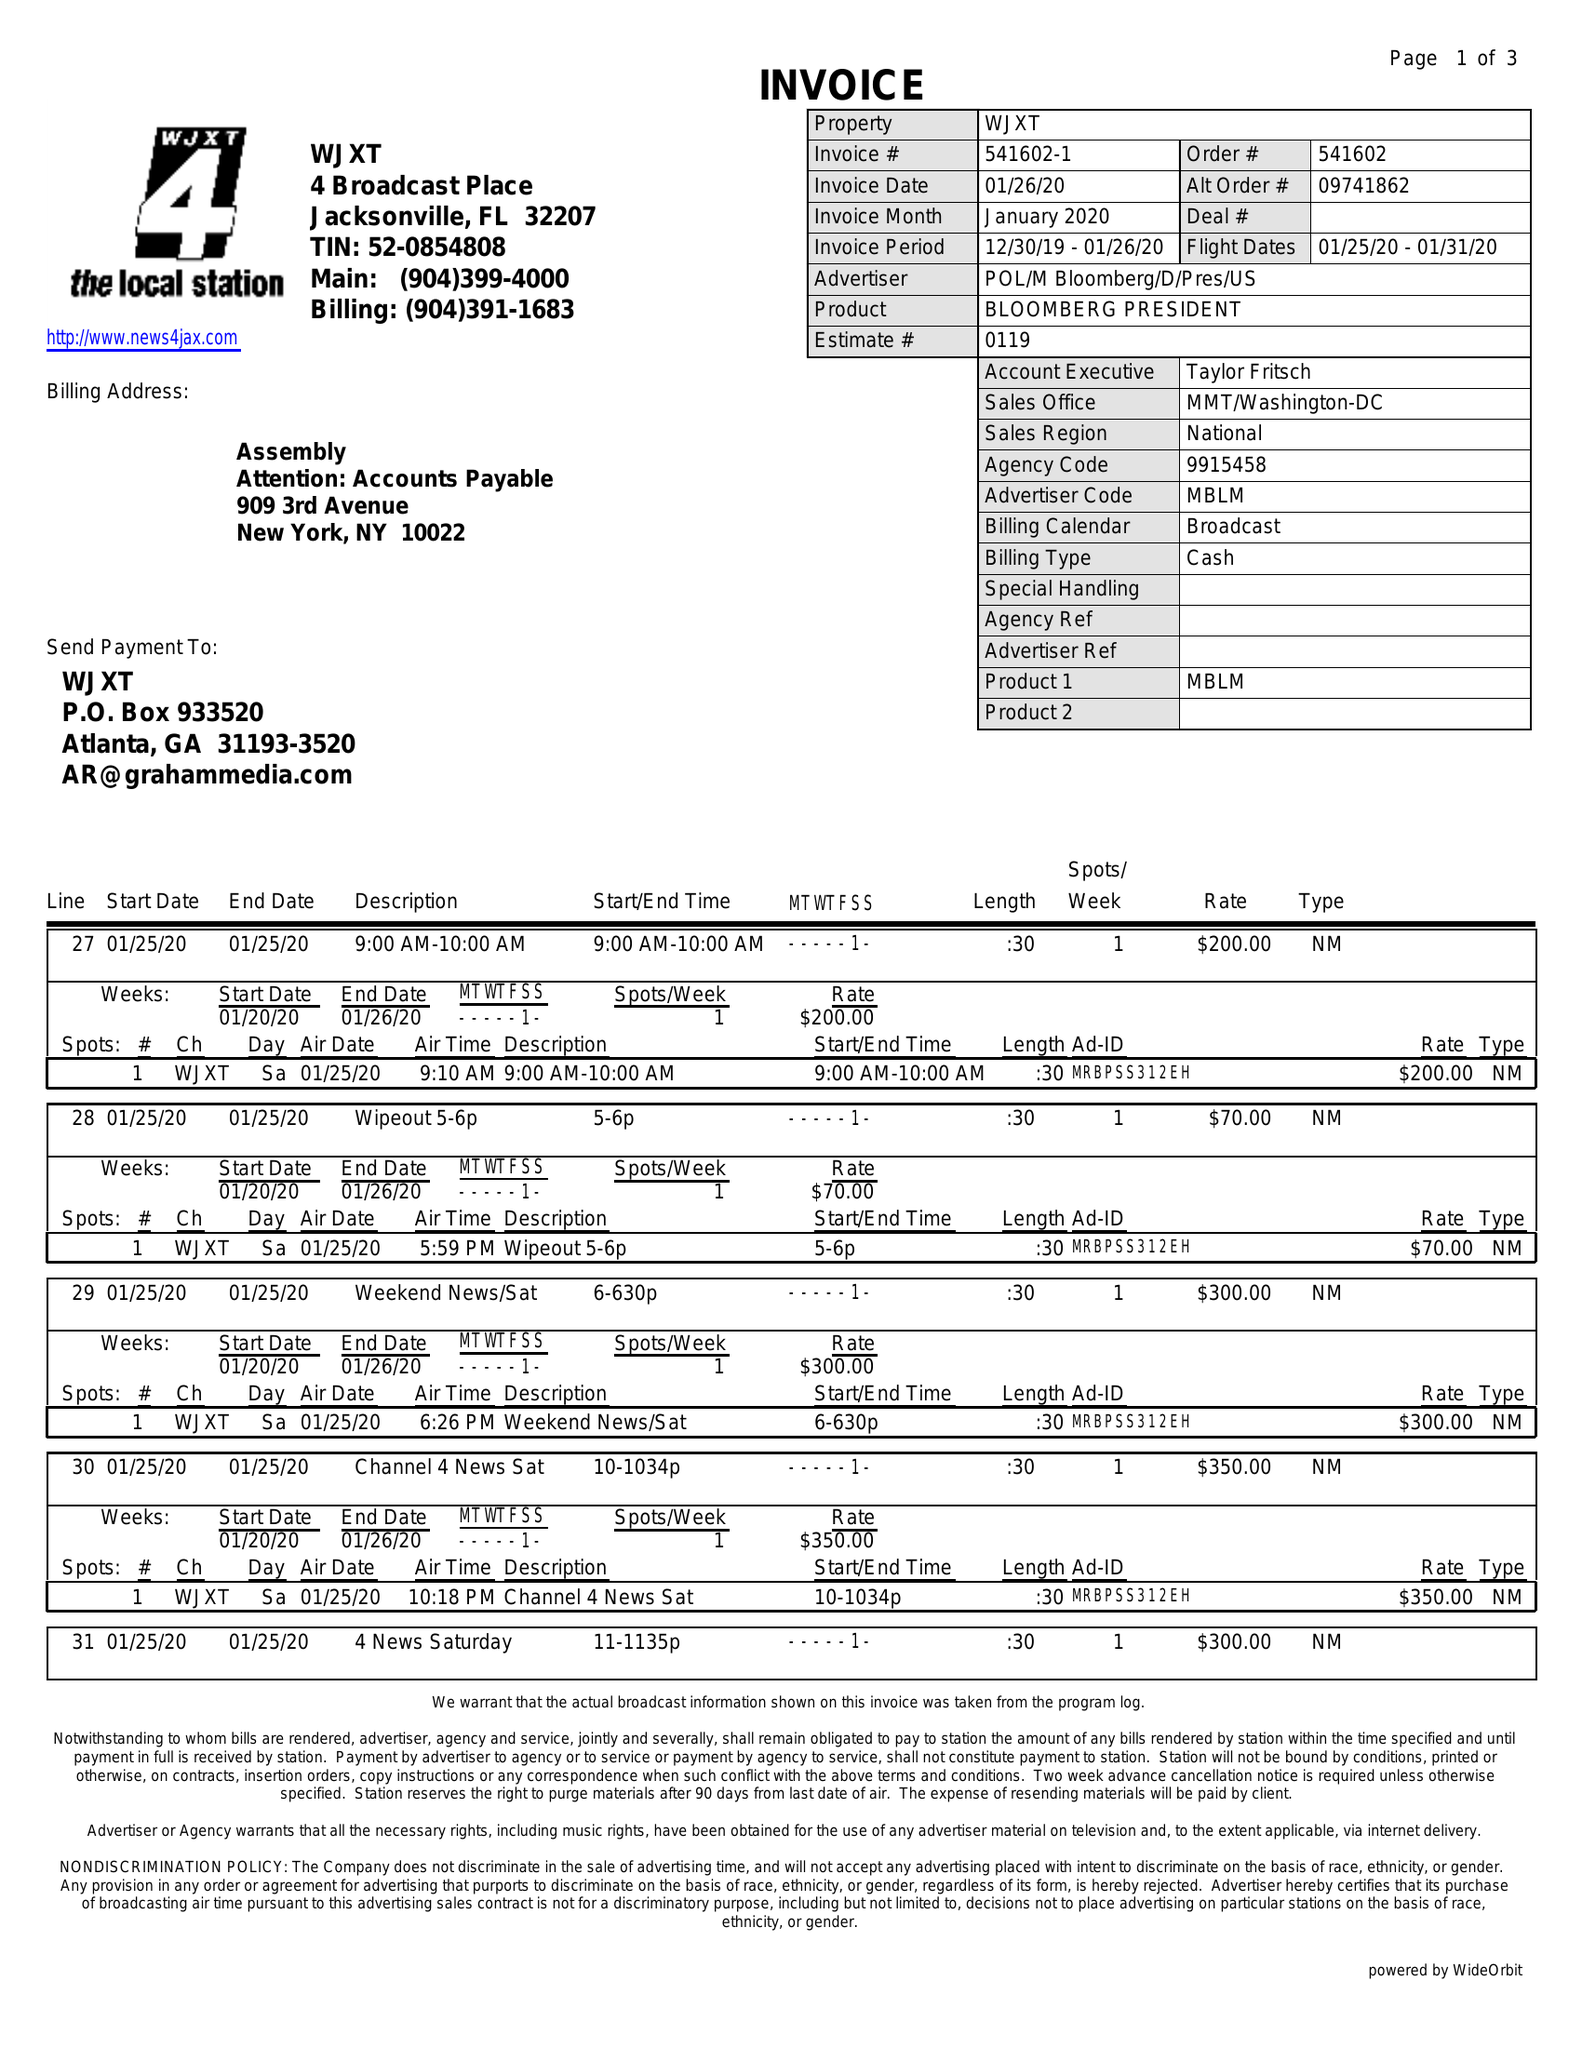What is the value for the flight_to?
Answer the question using a single word or phrase. 01/31/20 